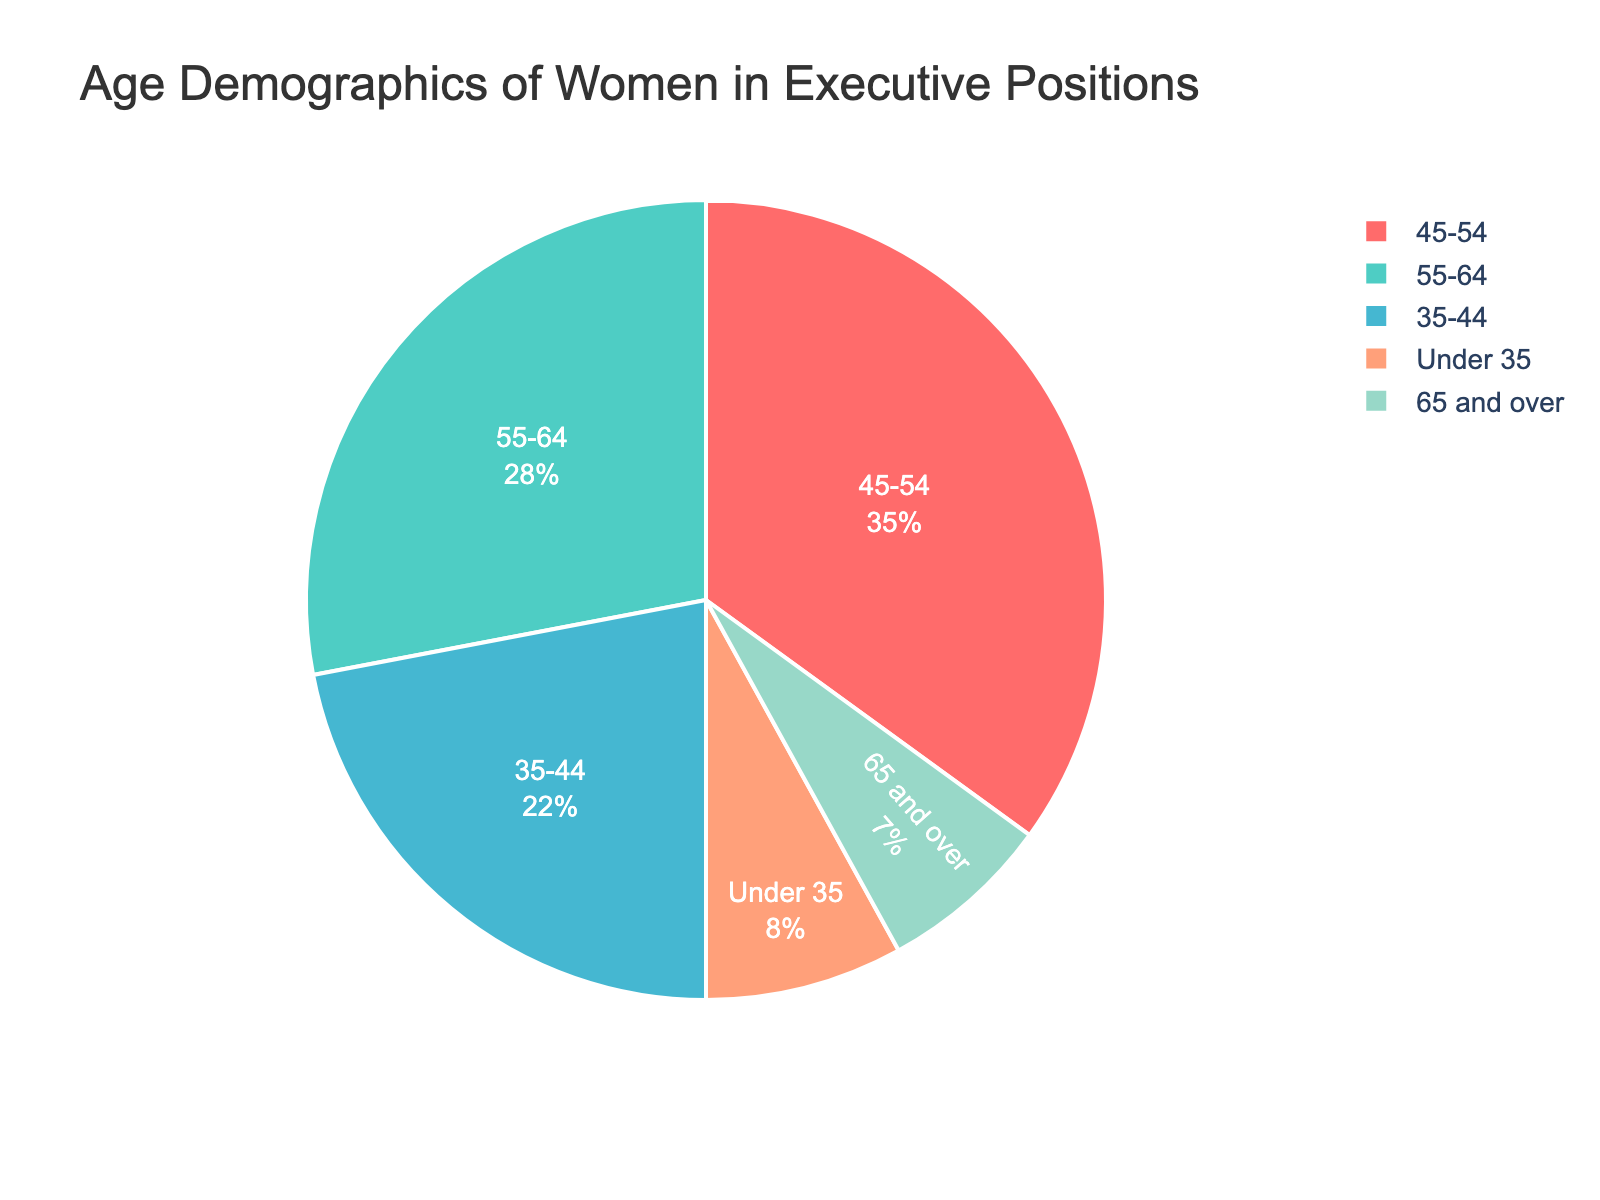What's the largest demographic age range for women in executive positions? By looking at the pie chart, you can see which age range occupies the largest section of the chart. The 45-54 age range is the largest.
Answer: 45-54 Which age range has the smallest percentage of women in executive positions? You need to find the smallest segment on the pie chart. The '65 and over' age range is the smallest slice.
Answer: 65 and over How much larger is the percentage of women aged 45-54 compared to those under 35? The percentage of women aged 45-54 is 35% and the percentage of those under 35 is 8%. The difference is 35% - 8% = 27%.
Answer: 27% What's the total percentage of women in executive positions aged 35-54? Add the percentages of the age ranges 35-44 and 45-54. (22% + 35% = 57%)
Answer: 57% Compare the sum of the percentages for women aged under 35 and 65 and over with the percentage of women aged 55-64. Is it larger, smaller, or equal? Sum the percentages of women under 35 and 65 and over: (8% + 7% = 15%). Compare this with the percentage of women aged 55-64 which is 28%. 15% is smaller than 28%.
Answer: Smaller Which demographic is represented by the green section of the pie chart? By looking at the color associated with the green section of the pie chart, you can identify the age range. The green section corresponds to the 35-44 age range.
Answer: 35-44 Is the percentage of women in executive positions aged 55-64 more or less than half of those aged 45-54? The percentage of women aged 55-64 is 28%, and for those aged 45-54 it is 35%. Half of 35% is 17.5%. Since 28% is more than 17.5%, the percentage of women aged 55-64 is more than half of those aged 45-54.
Answer: More What is the combined percentage of the age ranges that are not the dominant one? The dominant age range is 45-54 which is 35%. Add up the percentages of all other age ranges: 8% + 22% + 28% + 7% = 65%.
Answer: 65% 